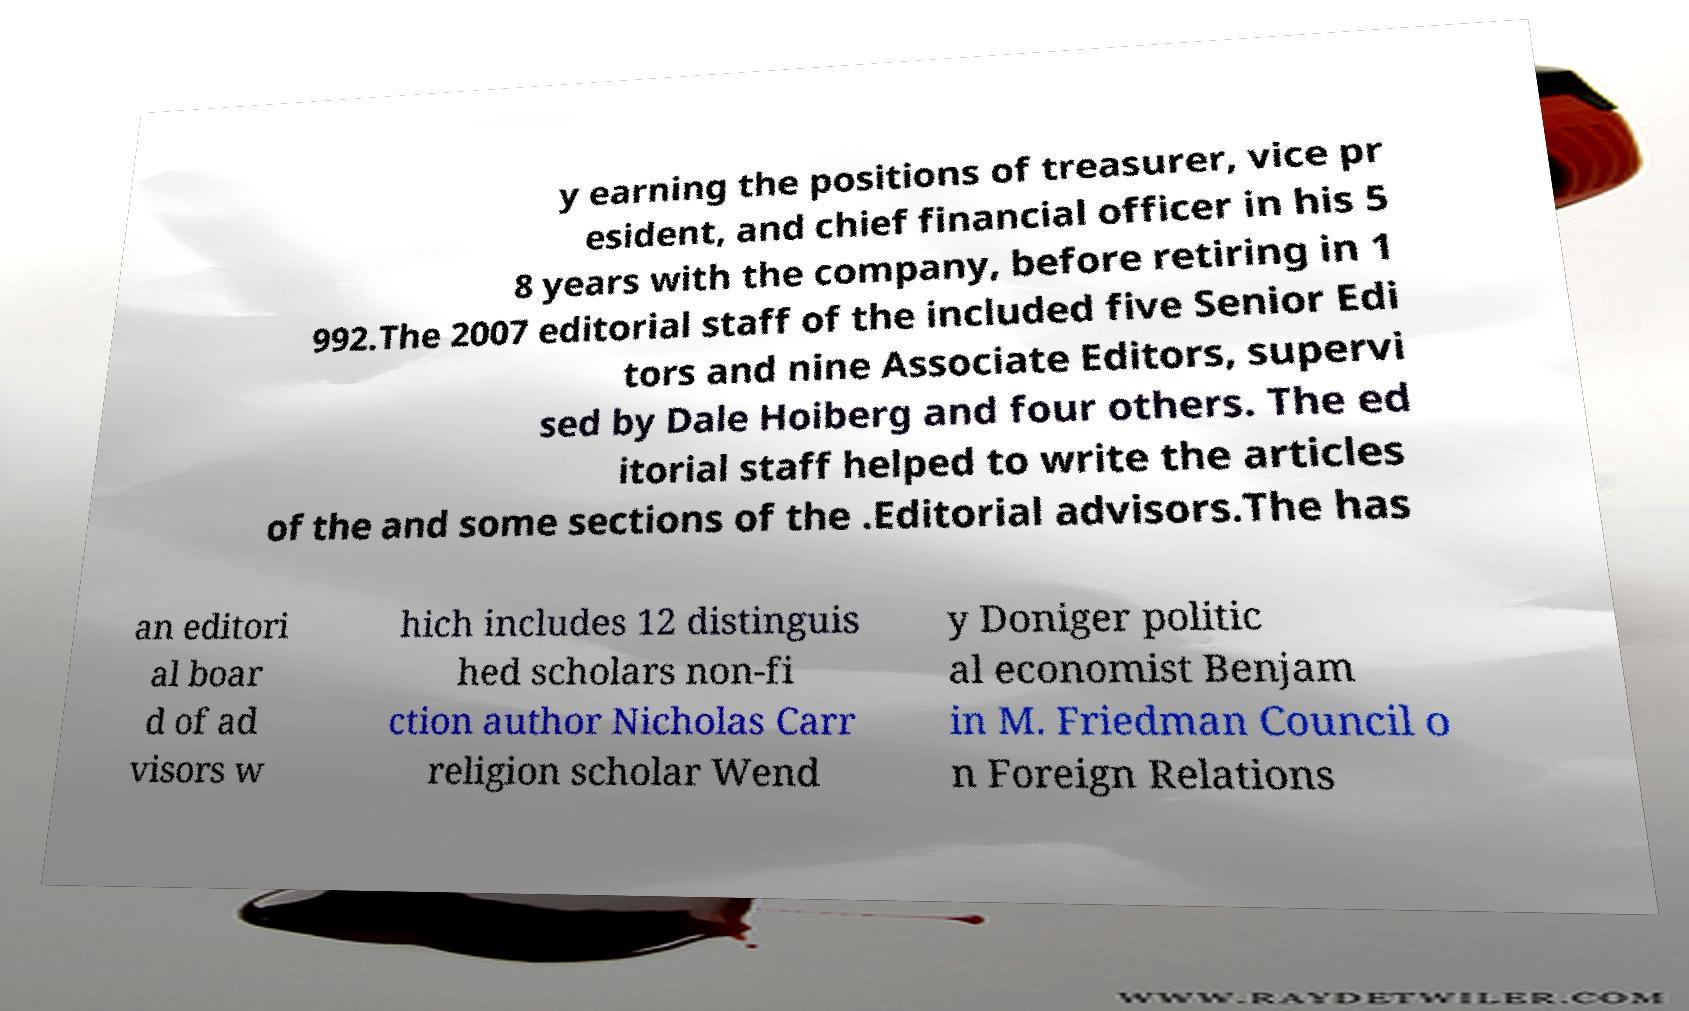Please identify and transcribe the text found in this image. y earning the positions of treasurer, vice pr esident, and chief financial officer in his 5 8 years with the company, before retiring in 1 992.The 2007 editorial staff of the included five Senior Edi tors and nine Associate Editors, supervi sed by Dale Hoiberg and four others. The ed itorial staff helped to write the articles of the and some sections of the .Editorial advisors.The has an editori al boar d of ad visors w hich includes 12 distinguis hed scholars non-fi ction author Nicholas Carr religion scholar Wend y Doniger politic al economist Benjam in M. Friedman Council o n Foreign Relations 